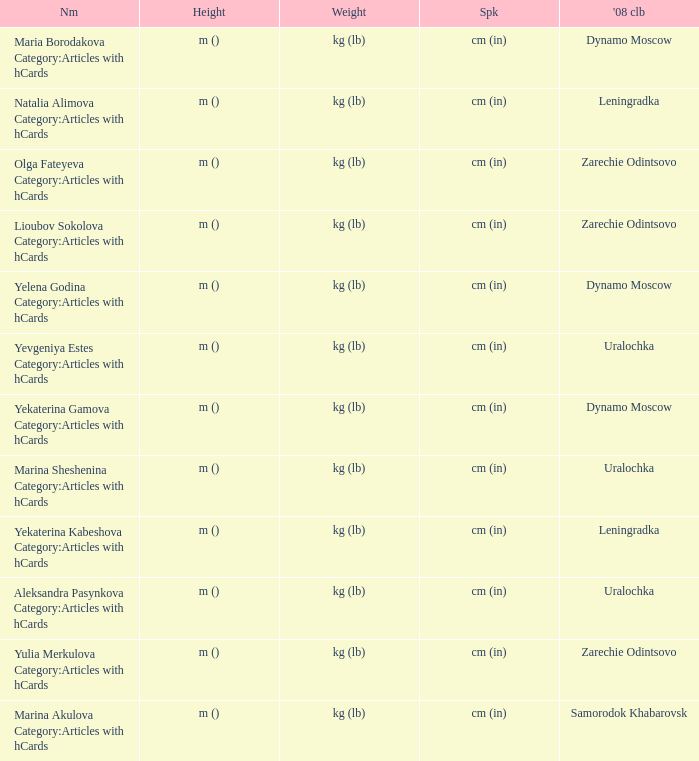What is the name when the 2008 club is zarechie odintsovo? Olga Fateyeva Category:Articles with hCards, Lioubov Sokolova Category:Articles with hCards, Yulia Merkulova Category:Articles with hCards. 